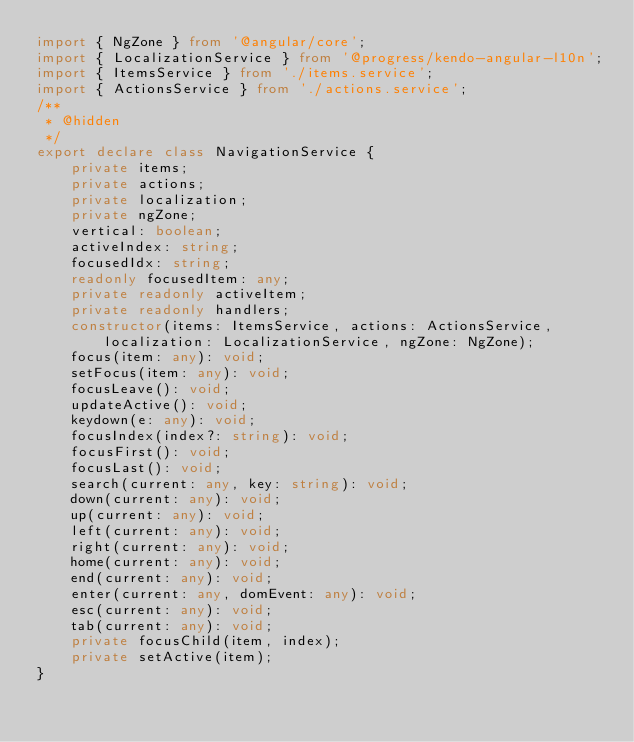<code> <loc_0><loc_0><loc_500><loc_500><_TypeScript_>import { NgZone } from '@angular/core';
import { LocalizationService } from '@progress/kendo-angular-l10n';
import { ItemsService } from './items.service';
import { ActionsService } from './actions.service';
/**
 * @hidden
 */
export declare class NavigationService {
    private items;
    private actions;
    private localization;
    private ngZone;
    vertical: boolean;
    activeIndex: string;
    focusedIdx: string;
    readonly focusedItem: any;
    private readonly activeItem;
    private readonly handlers;
    constructor(items: ItemsService, actions: ActionsService, localization: LocalizationService, ngZone: NgZone);
    focus(item: any): void;
    setFocus(item: any): void;
    focusLeave(): void;
    updateActive(): void;
    keydown(e: any): void;
    focusIndex(index?: string): void;
    focusFirst(): void;
    focusLast(): void;
    search(current: any, key: string): void;
    down(current: any): void;
    up(current: any): void;
    left(current: any): void;
    right(current: any): void;
    home(current: any): void;
    end(current: any): void;
    enter(current: any, domEvent: any): void;
    esc(current: any): void;
    tab(current: any): void;
    private focusChild(item, index);
    private setActive(item);
}
</code> 